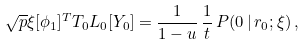Convert formula to latex. <formula><loc_0><loc_0><loc_500><loc_500>\sqrt { p } \xi [ \phi _ { 1 } ] ^ { T } { T } _ { 0 } { L } _ { 0 } [ Y _ { 0 } ] = \frac { 1 } { 1 - u } \, \frac { 1 } { t } \, P ( { 0 } \, | \, { r _ { 0 } } ; \xi ) \, ,</formula> 